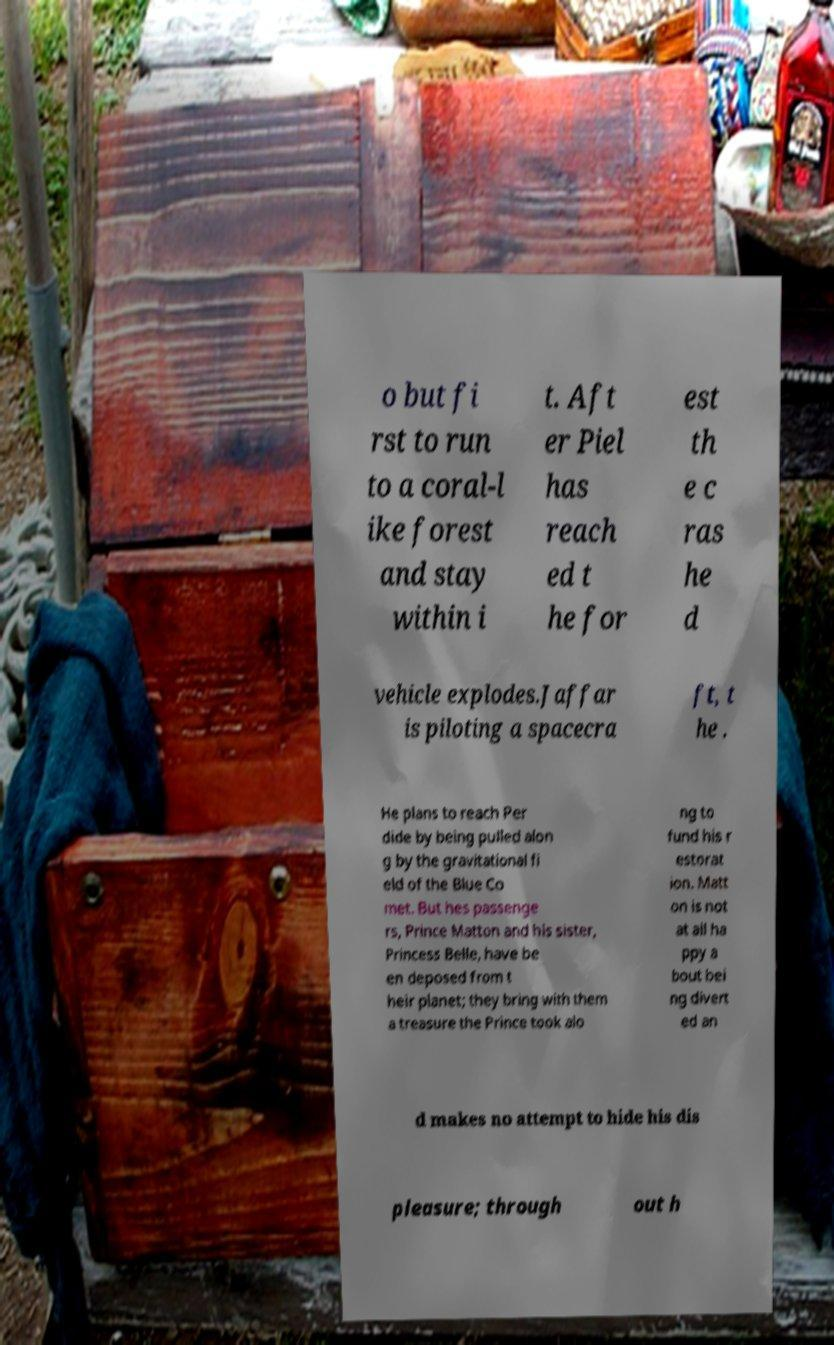Could you extract and type out the text from this image? o but fi rst to run to a coral-l ike forest and stay within i t. Aft er Piel has reach ed t he for est th e c ras he d vehicle explodes.Jaffar is piloting a spacecra ft, t he . He plans to reach Per dide by being pulled alon g by the gravitational fi eld of the Blue Co met. But hes passenge rs, Prince Matton and his sister, Princess Belle, have be en deposed from t heir planet; they bring with them a treasure the Prince took alo ng to fund his r estorat ion. Matt on is not at all ha ppy a bout bei ng divert ed an d makes no attempt to hide his dis pleasure; through out h 